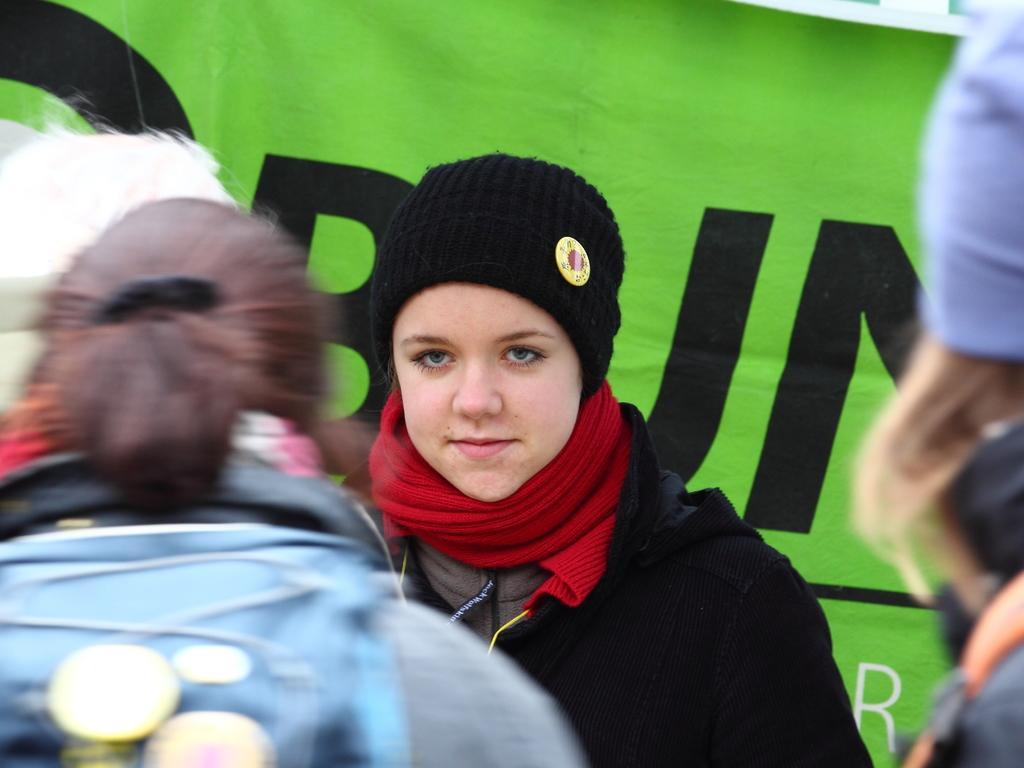How would you summarize this image in a sentence or two? In the foreground of this picture we can see the group of persons. In the center we can see a person wearing black color dress, black color hat and seems to be standing. In the background we can see the text on a green color object which seems to be the banner. 